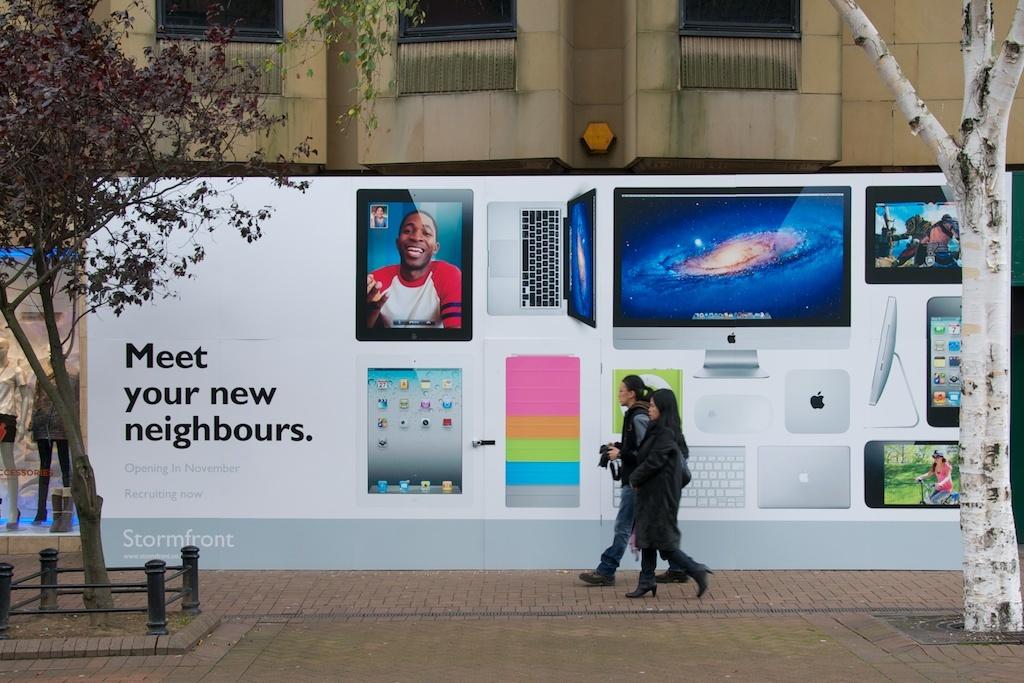What is the ad supporting?
Make the answer very short. Apple. What is the company name on the bottom left in the gray area?
Provide a short and direct response. Stormfront. 